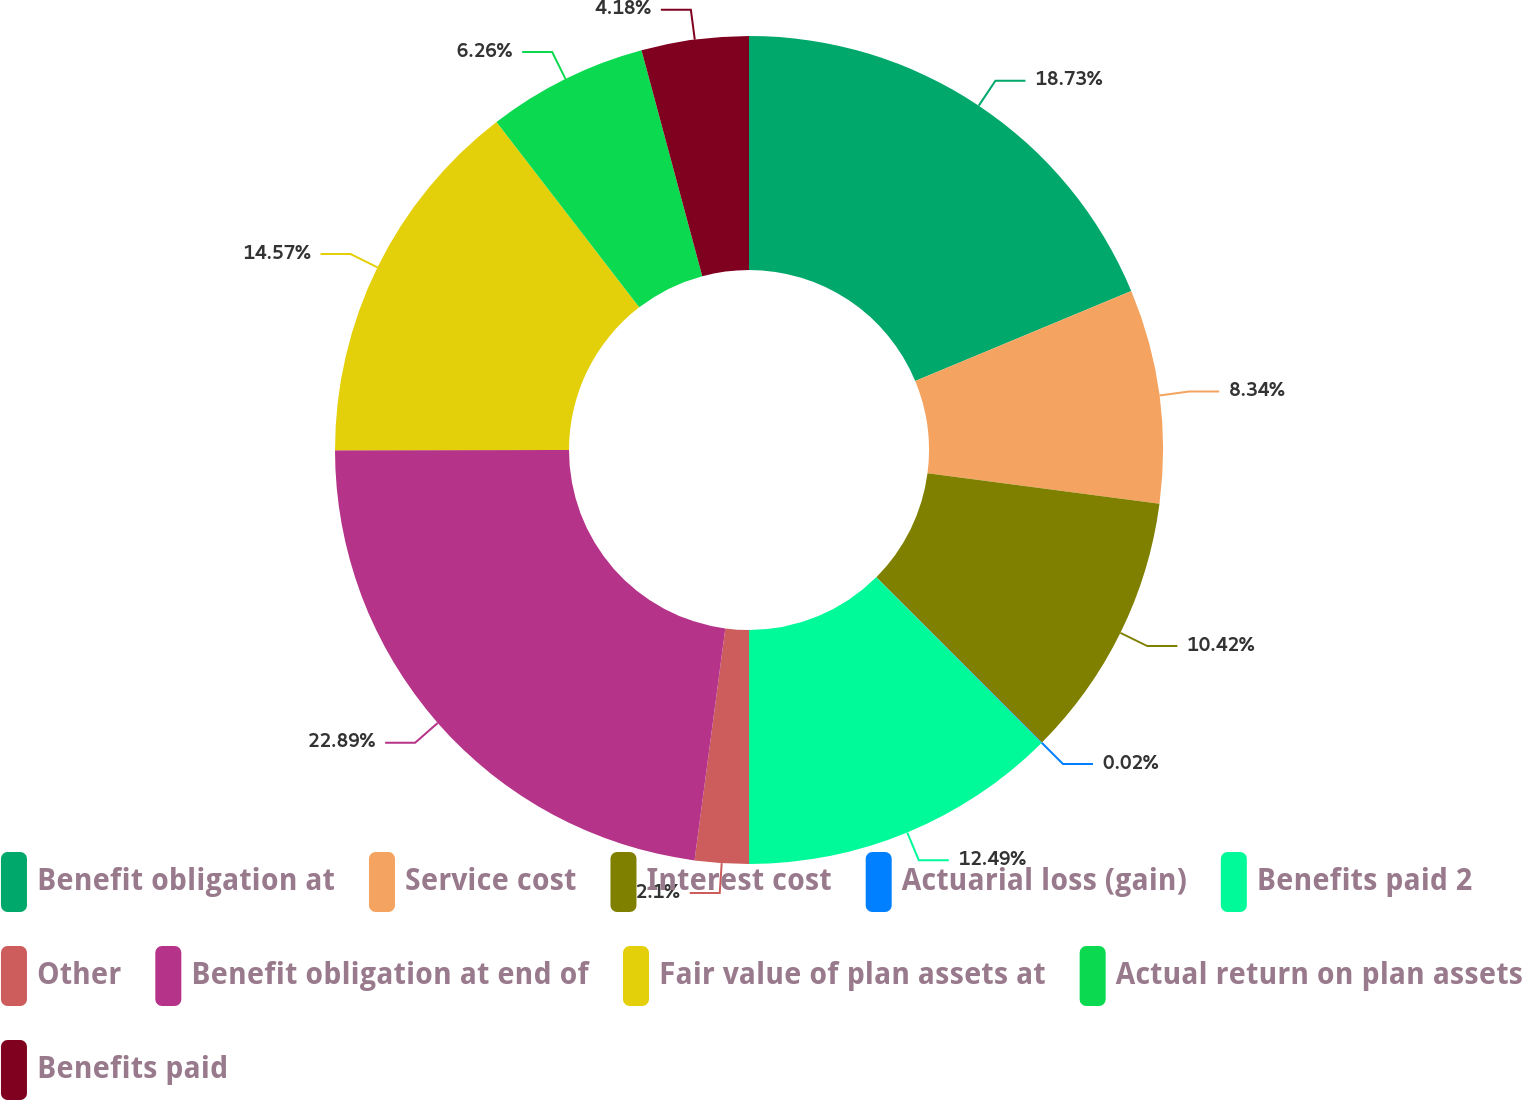Convert chart. <chart><loc_0><loc_0><loc_500><loc_500><pie_chart><fcel>Benefit obligation at<fcel>Service cost<fcel>Interest cost<fcel>Actuarial loss (gain)<fcel>Benefits paid 2<fcel>Other<fcel>Benefit obligation at end of<fcel>Fair value of plan assets at<fcel>Actual return on plan assets<fcel>Benefits paid<nl><fcel>18.73%<fcel>8.34%<fcel>10.42%<fcel>0.02%<fcel>12.49%<fcel>2.1%<fcel>22.89%<fcel>14.57%<fcel>6.26%<fcel>4.18%<nl></chart> 